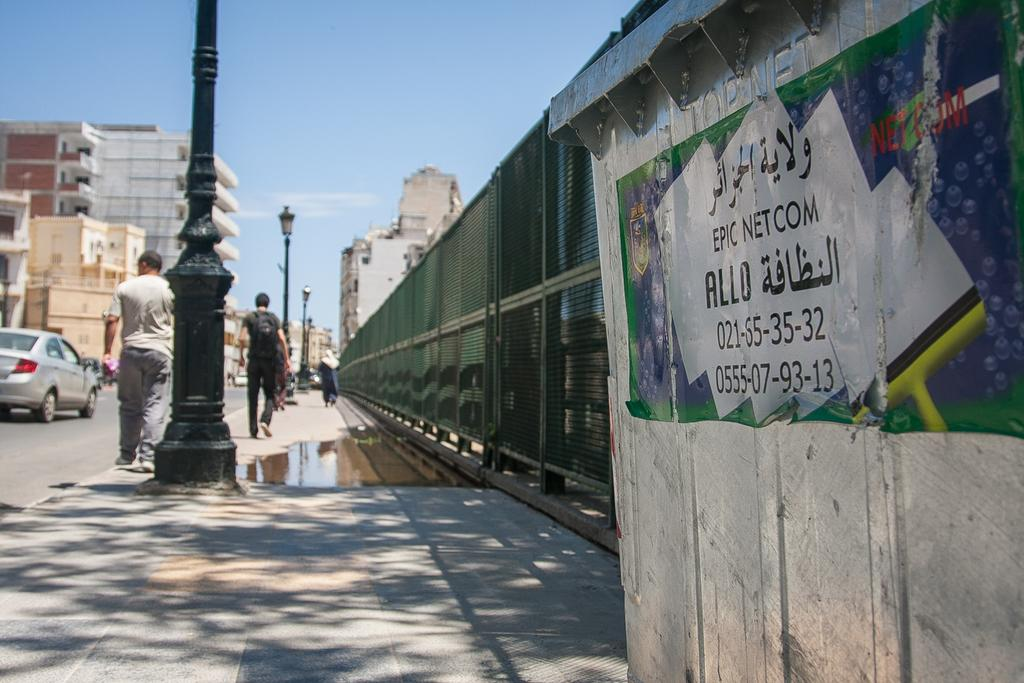<image>
Write a terse but informative summary of the picture. A banner by Epic Netcom is on display on a busy street. 